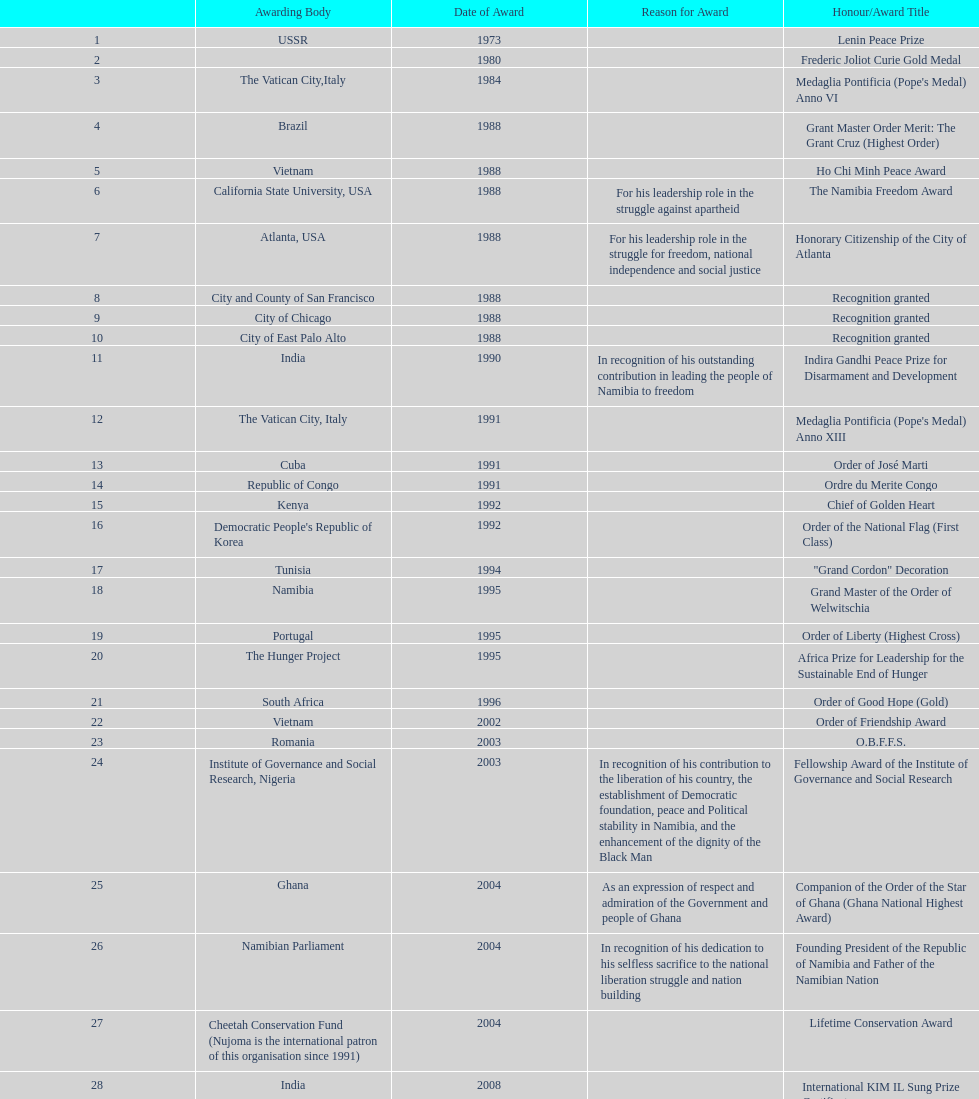What is the most recent award nujoma received? Sir Seretse Khama SADC Meda. 